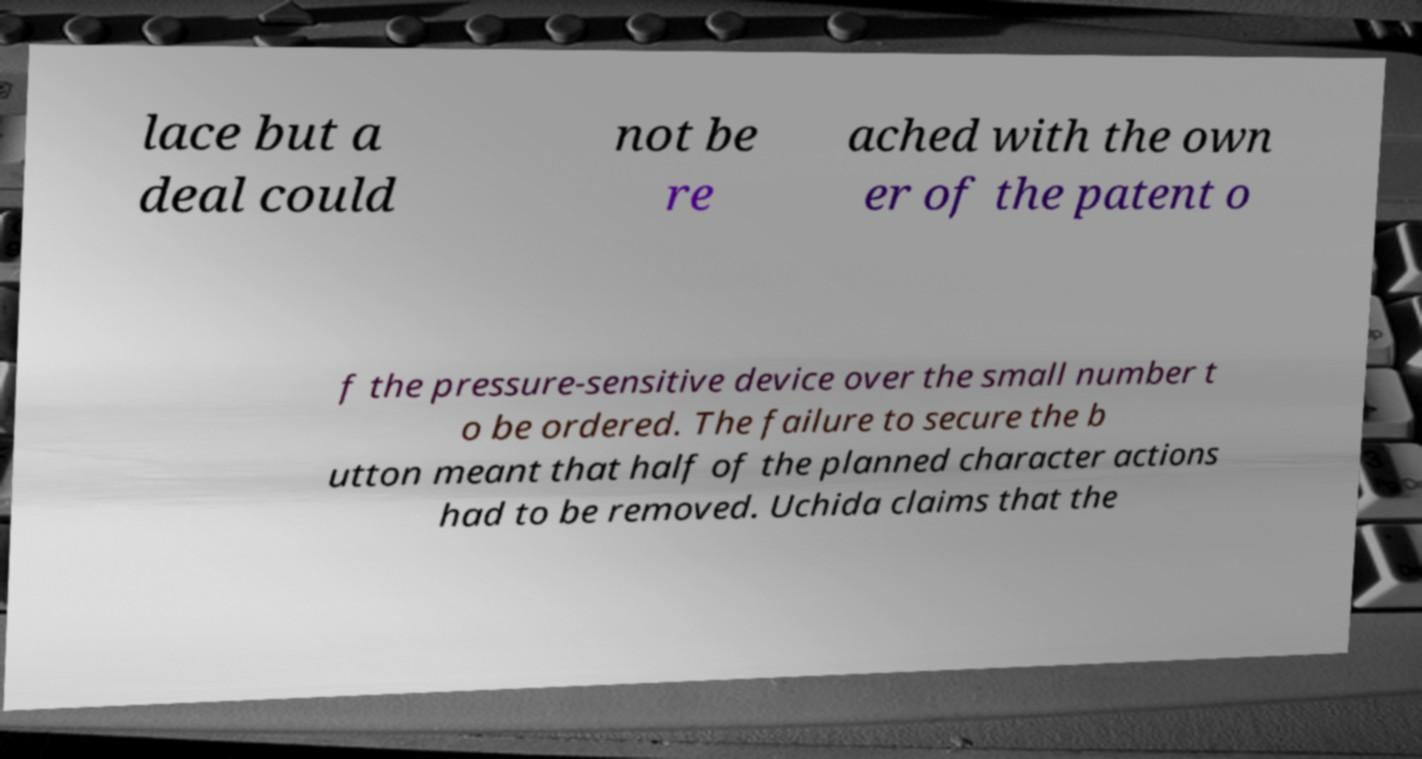Could you extract and type out the text from this image? lace but a deal could not be re ached with the own er of the patent o f the pressure-sensitive device over the small number t o be ordered. The failure to secure the b utton meant that half of the planned character actions had to be removed. Uchida claims that the 